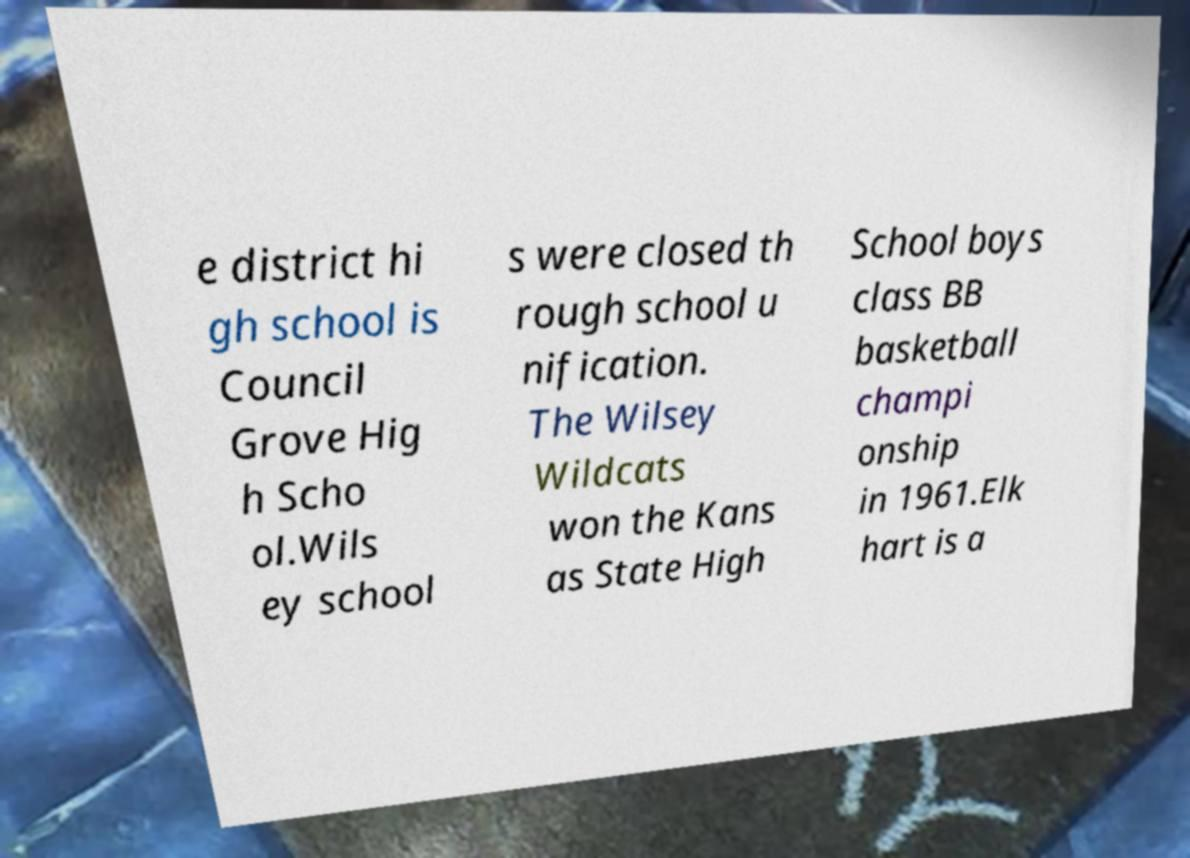Could you assist in decoding the text presented in this image and type it out clearly? e district hi gh school is Council Grove Hig h Scho ol.Wils ey school s were closed th rough school u nification. The Wilsey Wildcats won the Kans as State High School boys class BB basketball champi onship in 1961.Elk hart is a 